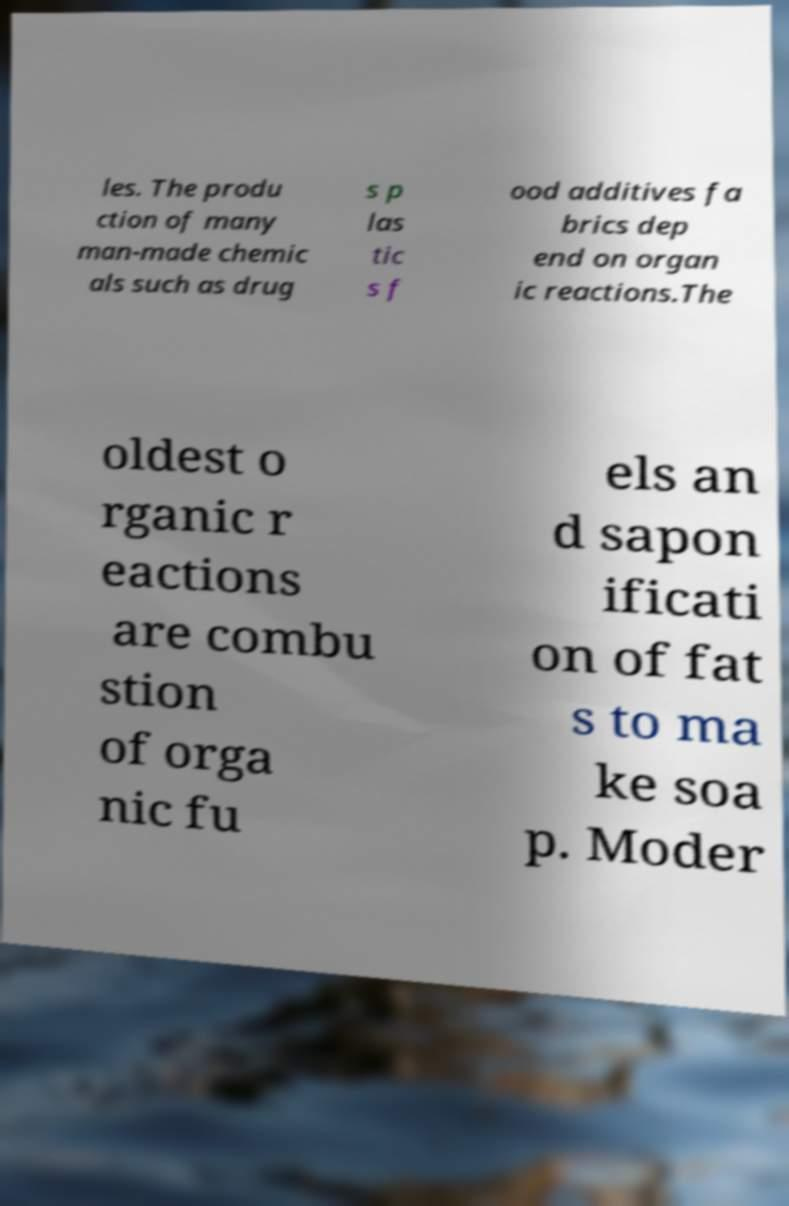Please identify and transcribe the text found in this image. les. The produ ction of many man-made chemic als such as drug s p las tic s f ood additives fa brics dep end on organ ic reactions.The oldest o rganic r eactions are combu stion of orga nic fu els an d sapon ificati on of fat s to ma ke soa p. Moder 